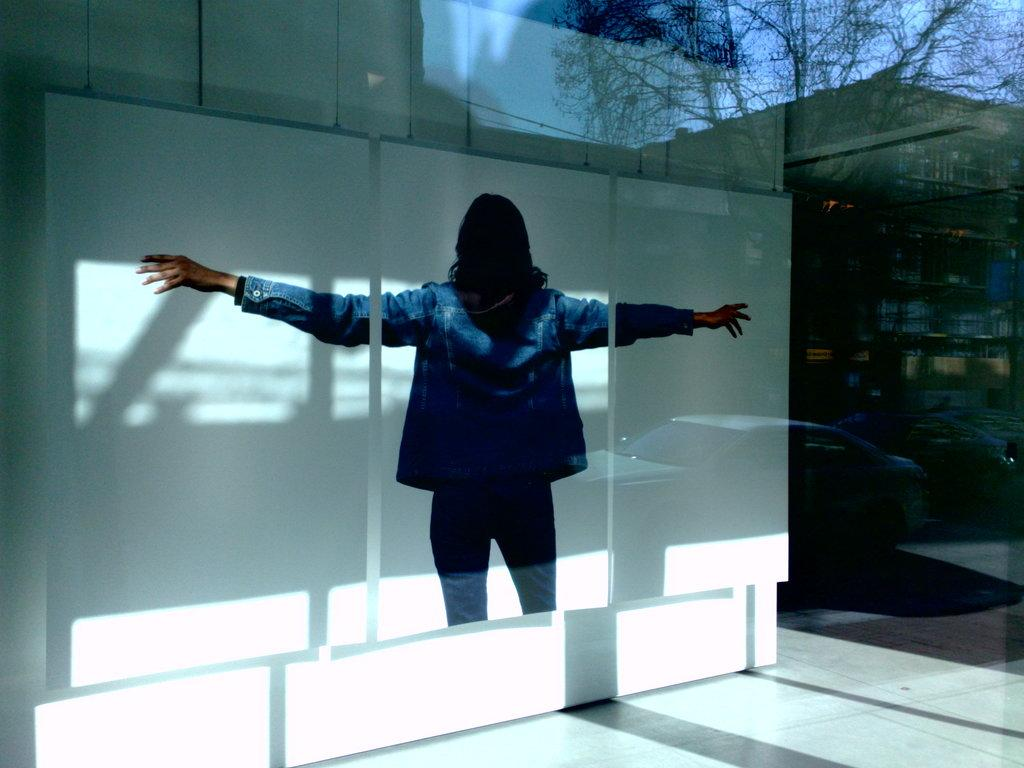What is the main subject in the image? There is a person standing in the image. What can be seen through the glass object in the image? Trees, buildings, cars, and the sky are visible through the glass. Can you describe the glass object in the image? It is a glass object that allows the person to see through it. What type of hair is visible on the person's head in the image? There is no information about the person's hair in the provided facts, so we cannot answer this question. Can you provide an example of a similar glass object in another context? The provided facts only describe the glass object in this specific image, so we cannot provide an example of a similar glass object in another context. 